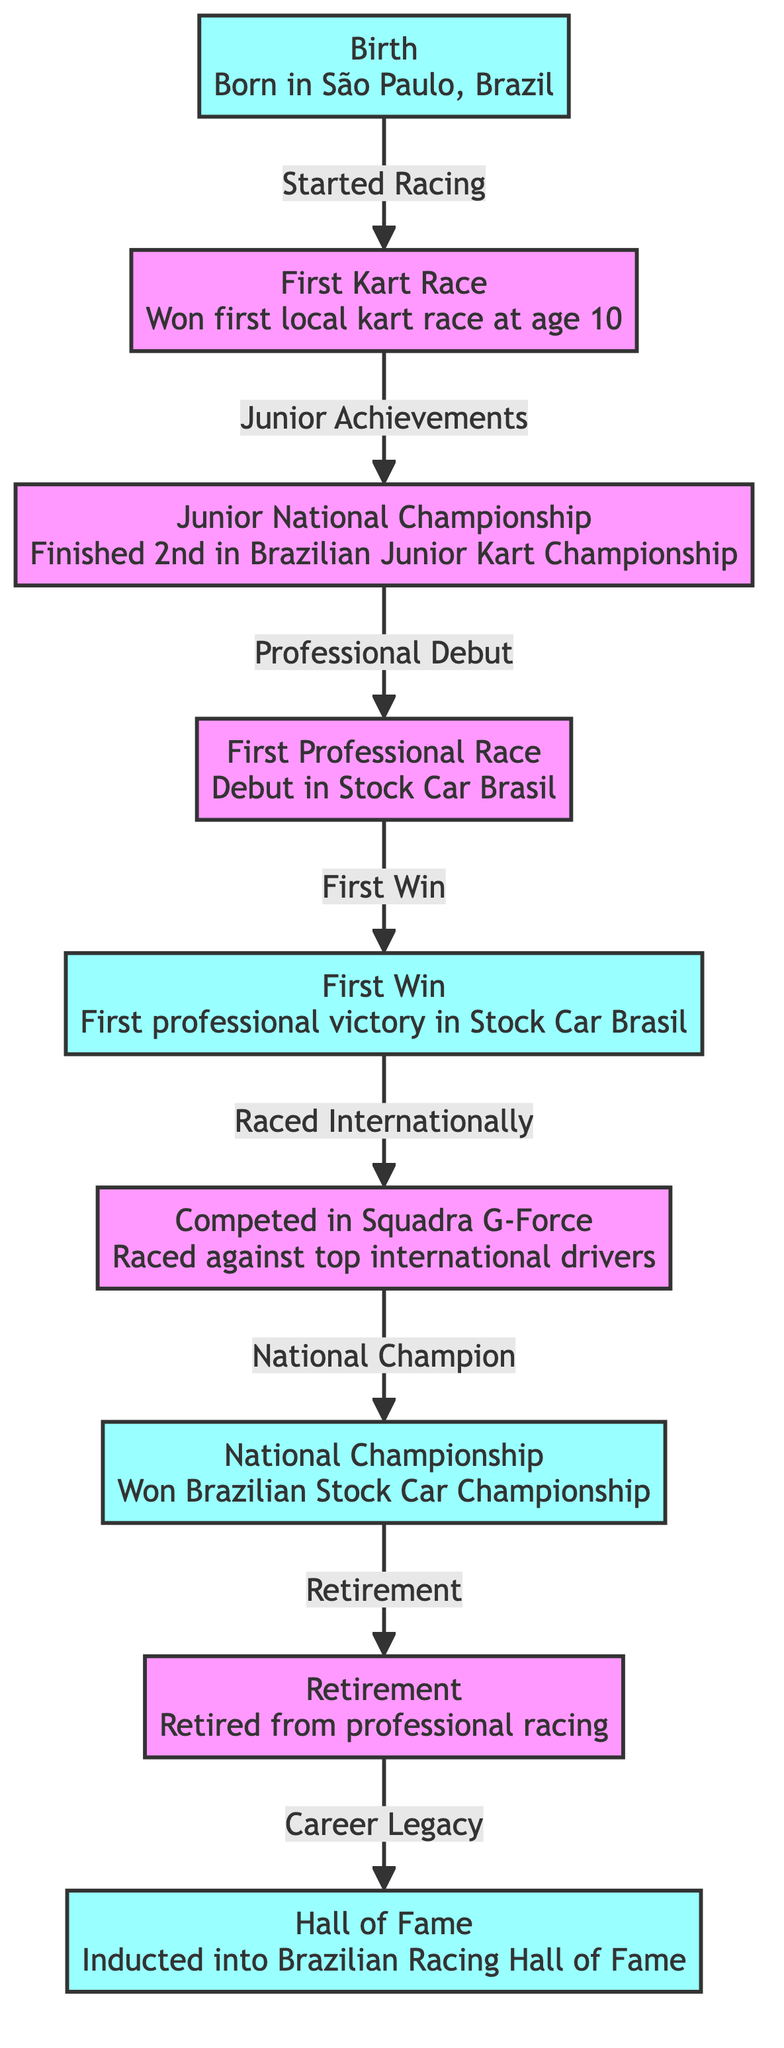What's the milestone marked first in the timeline? The first milestone in the timeline is marked by "Birth", as indicated by the first node in the diagram.
Answer: Birth How many nodes are in the timeline? The diagram has a total of nine nodes, each representing a major event or milestone in the racing career.
Answer: 9 What event follows the "First Kart Race" in the timeline? After "First Kart Race," the next event noted is "Junior National Championship," reflecting the progression from kart racing to competing at a national level.
Answer: Junior National Championship What is the last event in the timeline? The last event in the timeline is "Hall of Fame," which signifies the final honor received after retirement from racing.
Answer: Hall of Fame Which event is associated with competing against Squadra G-Force? The event associated with competing against Squadra G-Force is "Competed in Squadra G-Force," which shows the connection between this experience and racing internationally.
Answer: Competed in Squadra G-Force What milestone occurs immediately before "Retirement"? The milestone that occurs immediately before "Retirement" is "National Championship," indicating success before stepping back from professional racing.
Answer: National Championship What kind of relationship exists between "First Win" and "Raced Internationally"? The relationship described is a direct sequential progression where "First Win" leads to the experience of racing internationally.
Answer: First Win to Raced Internationally Which two milestones are depicted as significant achievements? The significant achievements highlighted in the diagram are "National Championship" and "Hall of Fame," each representing prestigious accomplishments in the racing career.
Answer: National Championship and Hall of Fame Which event signifies the start of a racing career? The event that signifies the start of a racing career is "First Professional Race," representing the transition from amateur to professional racing.
Answer: First Professional Race 